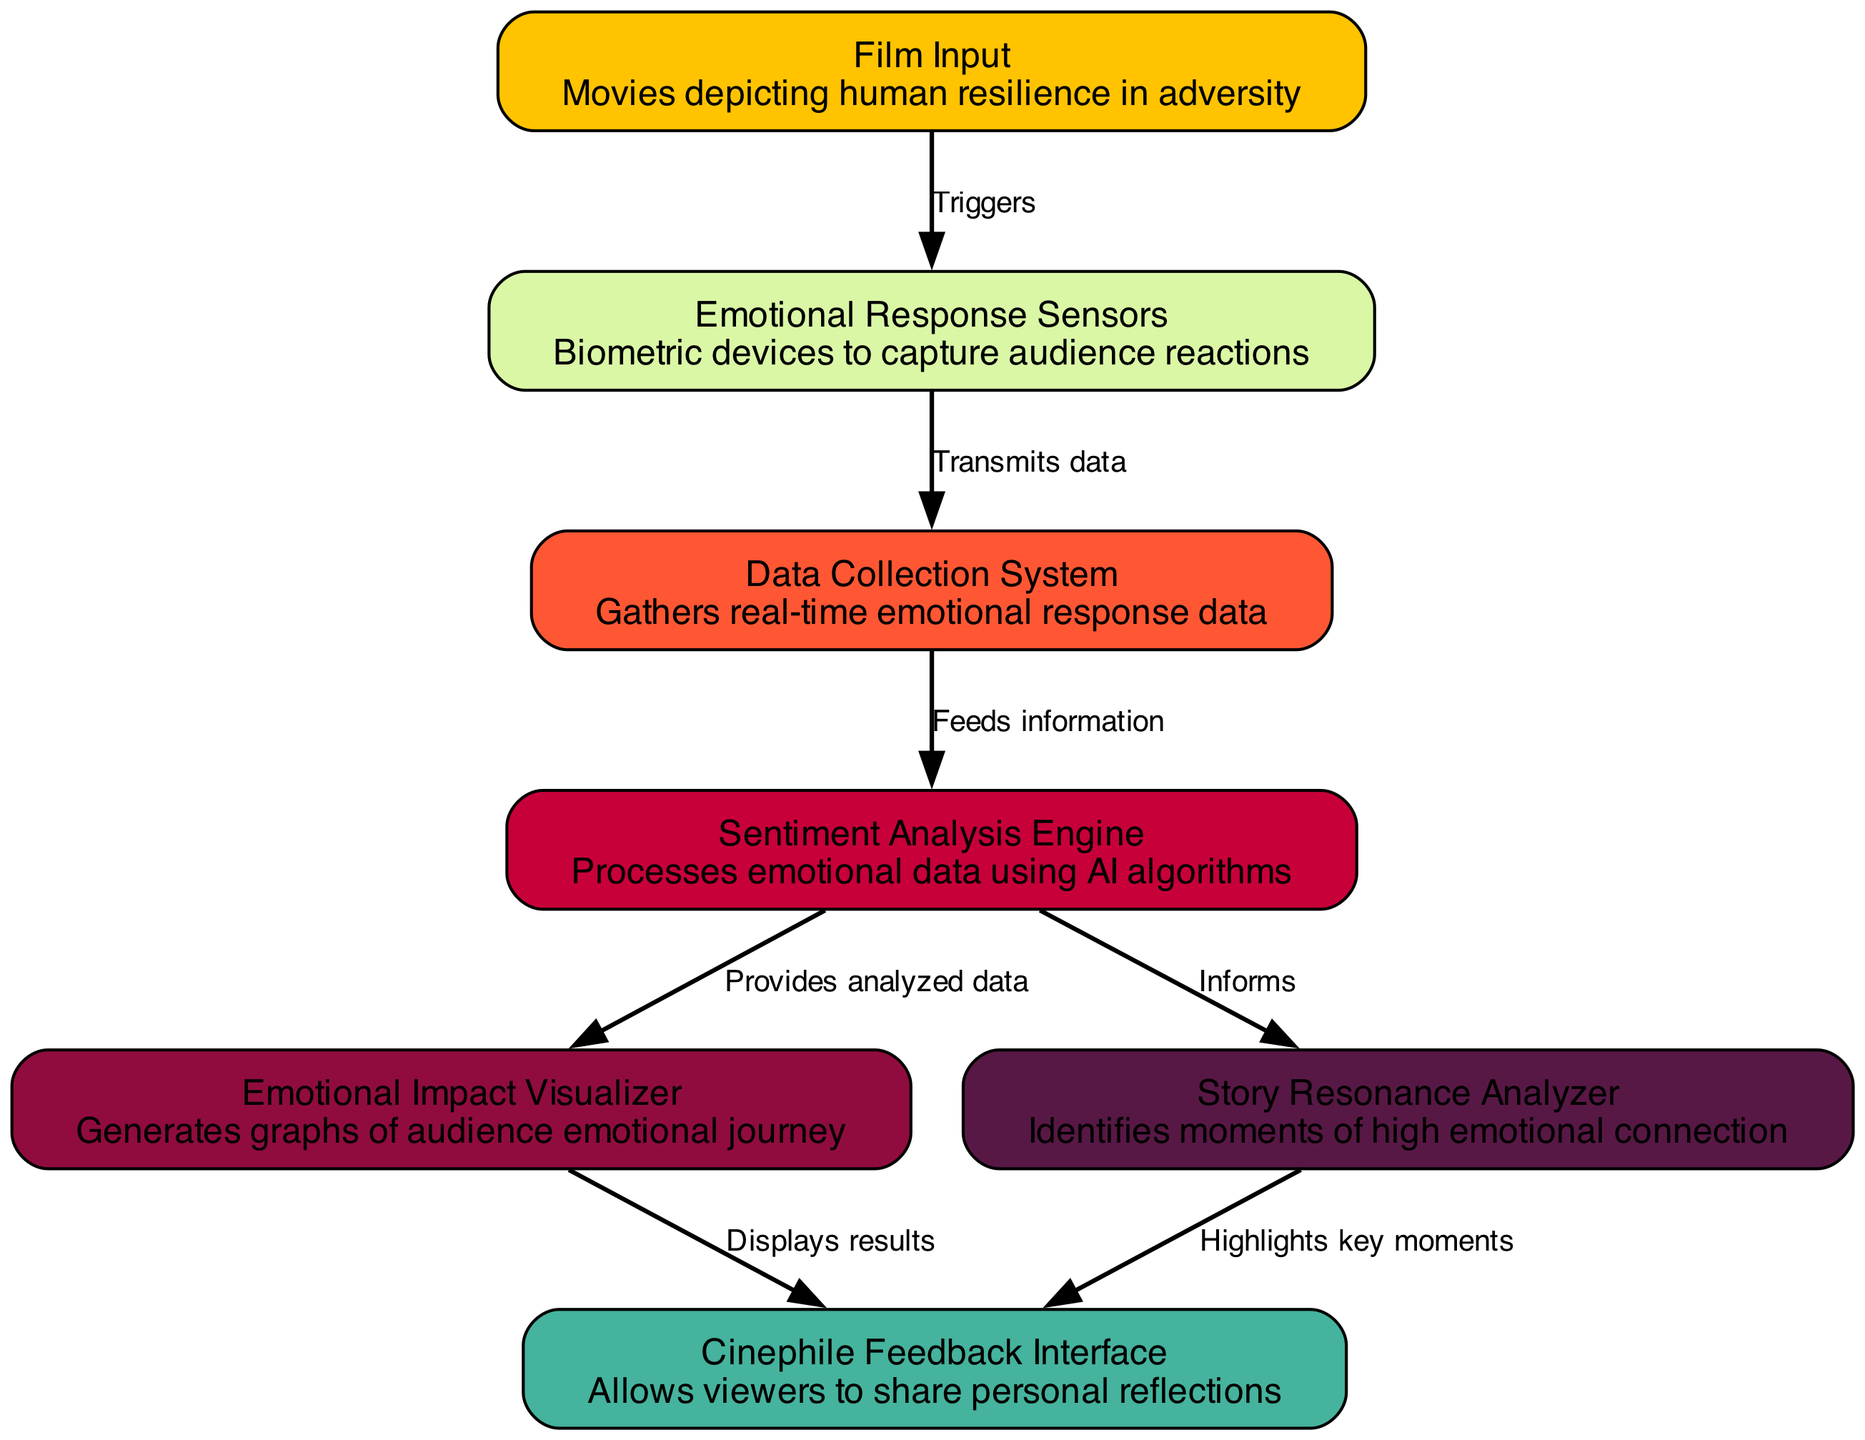What is the total number of nodes in the diagram? The diagram lists a total of 7 nodes: Film Input, Emotional Response Sensors, Data Collection System, Sentiment Analysis Engine, Emotional Impact Visualizer, Story Resonance Analyzer, and Cinephile Feedback Interface.
Answer: 7 What is the role of the 'Sentiment Analysis Engine'? The 'Sentiment Analysis Engine' processes emotional data using AI algorithms as indicated in its description within the diagram.
Answer: Processes emotional data using AI algorithms What is the connection between 'Emotional Response Sensors' and 'Data Collection System'? The edge between 'Emotional Response Sensors' and 'Data Collection System' shows that the sensors transmit data to the system, facilitating the flow of emotional responses.
Answer: Transmits data Which node sends results to the 'Cinephile Feedback Interface'? The 'Emotional Impact Visualizer' sends results to the 'Cinephile Feedback Interface' as shown by the edge labeled "Displays results" in the diagram.
Answer: Emotional Impact Visualizer How many edges are in the diagram? By counting the connections (edges) listed in the diagram, there are 7 edges connecting various nodes, indicating the flow of emotions and insights.
Answer: 7 What does the 'Story Resonance Analyzer' highlight? The 'Story Resonance Analyzer' identifies moments of high emotional connection, as explicitly stated in the description section of the diagram.
Answer: Moments of high emotional connection What triggers the 'Emotional Response Sensors'? The 'Film Input' node triggers the 'Emotional Response Sensors' as indicated by the directed edge labeled "Triggers" connecting these two nodes.
Answer: Triggers Which node provides analyzed data to the 'Emotional Impact Visualizer'? The 'Sentiment Analysis Engine' provides analyzed data to the 'Emotional Impact Visualizer', connecting them through a directed edge labeled "Provides analyzed data."
Answer: Sentiment Analysis Engine What is the output of the connection from 'Story Resonance Analyzer' to 'Cinephile Feedback Interface'? The connection signifies that the 'Story Resonance Analyzer' highlights key moments, which are then shared through the 'Cinephile Feedback Interface', allowing viewers to reflect on those moments.
Answer: Highlights key moments 